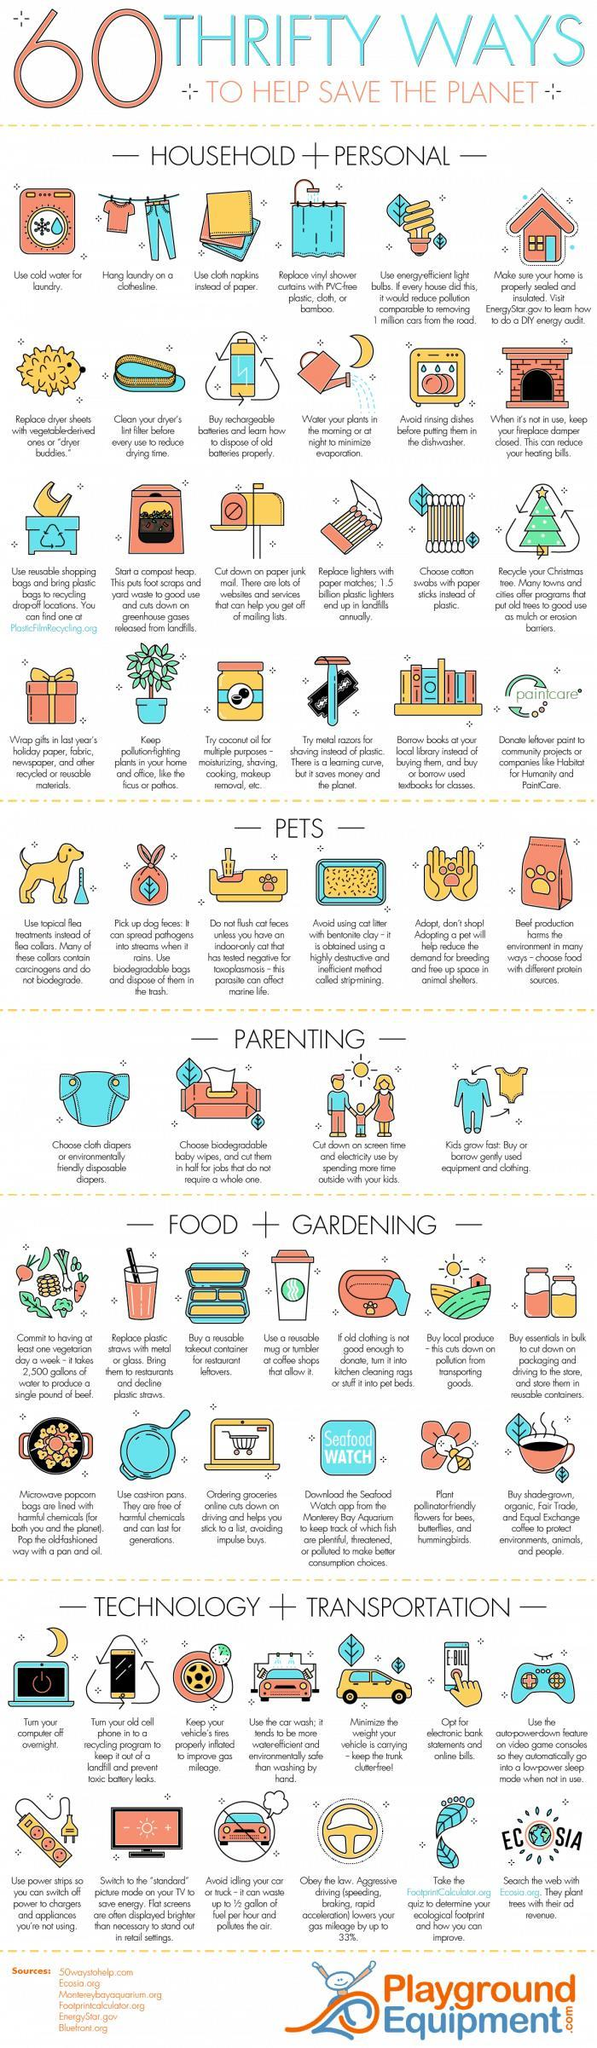What sort of take out containers or mugs are recommended
Answer the question with a short phrase. reusable What does the washing machine indicate Use cold water for laundry what all can coconut oil be used for moisturizing, shaving, cooking, makeup removal What are some examples of pollution-fighting plants ficus or pothos What contains carcinogens and do not biodegrade flea collars What does Ecosia do the plant trees with their ad revenue How can drying time be reduced clean your dryer's lint filter before every use how can gas mileage be improved keep your vehicle's tires properly inflated 